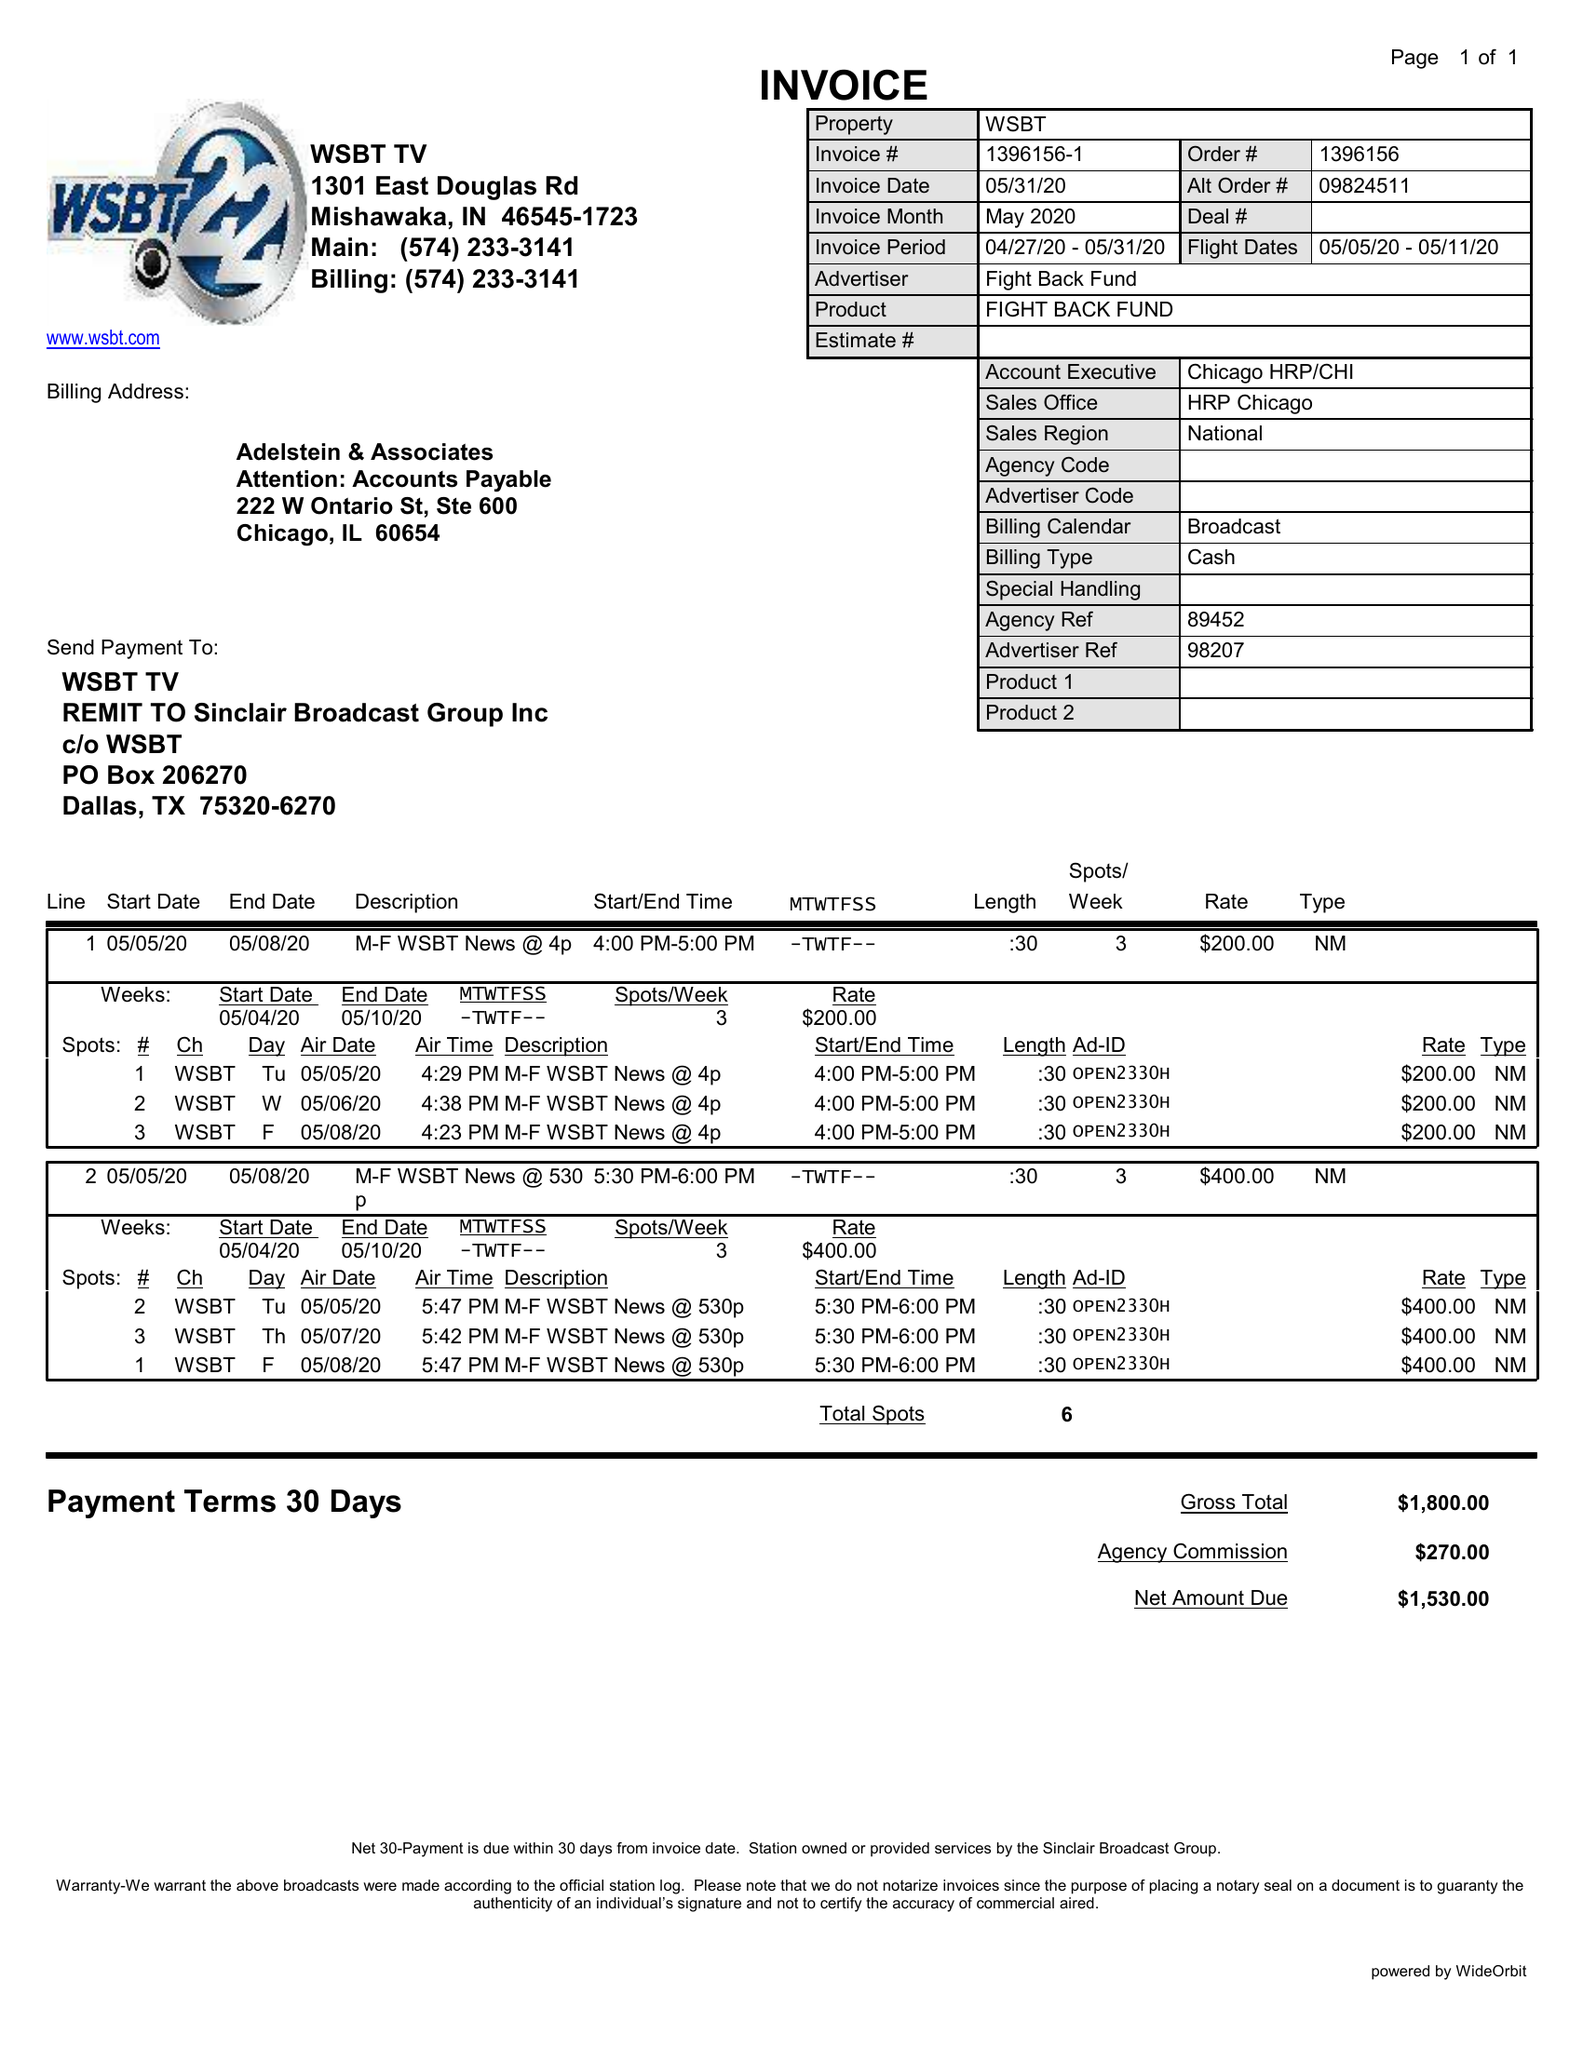What is the value for the gross_amount?
Answer the question using a single word or phrase. 1800.00 